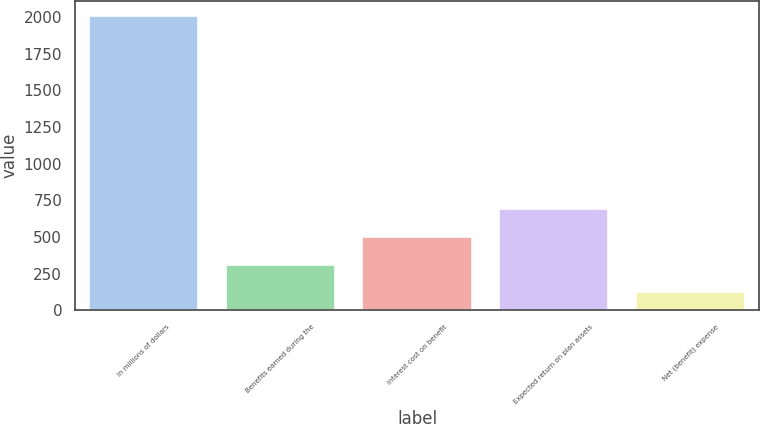Convert chart. <chart><loc_0><loc_0><loc_500><loc_500><bar_chart><fcel>In millions of dollars<fcel>Benefits earned during the<fcel>Interest cost on benefit<fcel>Expected return on plan assets<fcel>Net (benefit) expense<nl><fcel>2007<fcel>311.4<fcel>499.8<fcel>688.2<fcel>123<nl></chart> 